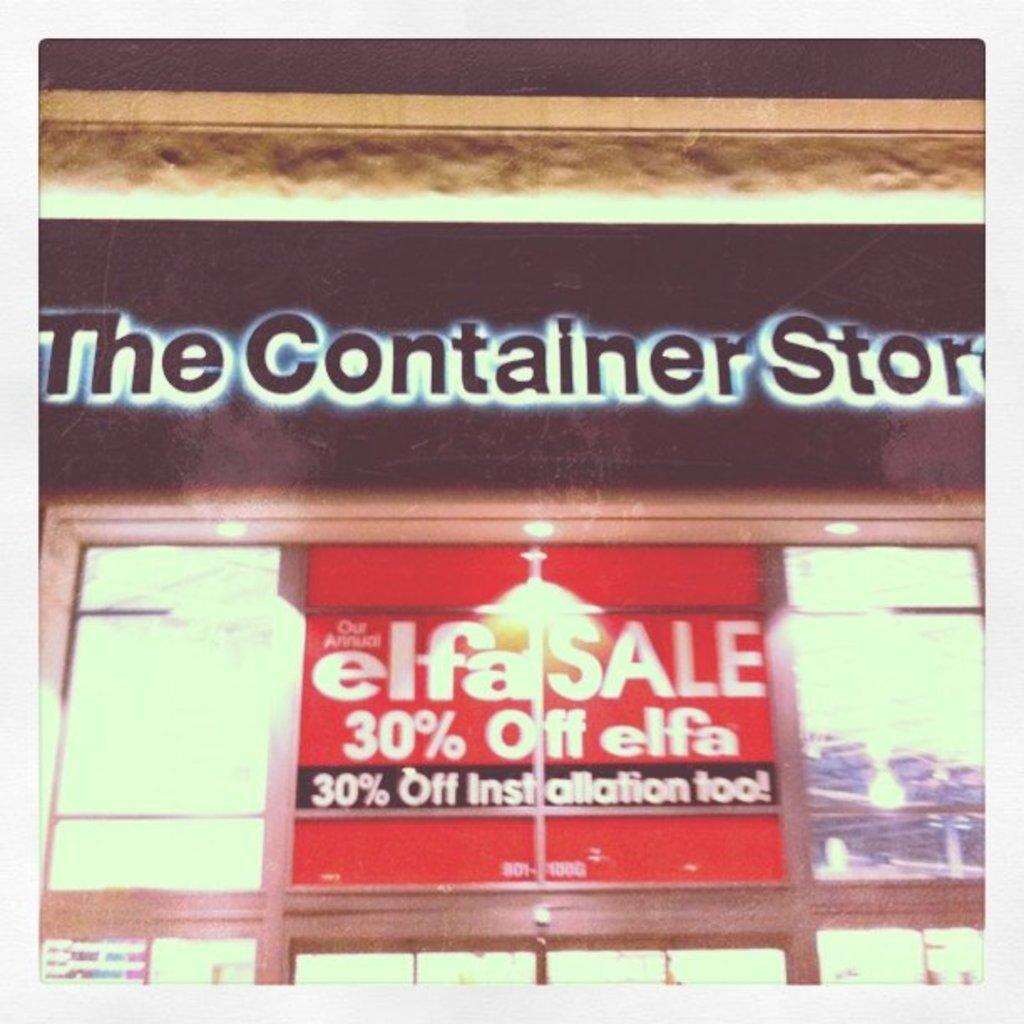What is 30% off?
Your response must be concise. Elfa. What store is this?
Ensure brevity in your answer.  The container store. 